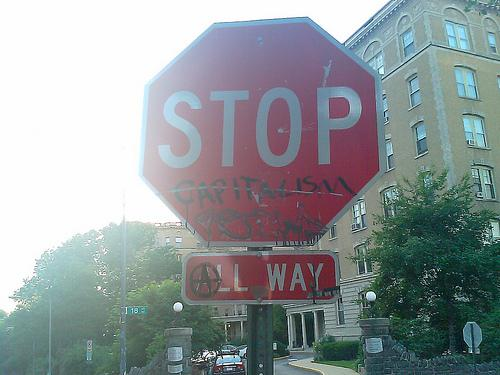Write a headline for a news article about the scene in the image. "Capitalism" Defaces Iconic Stop Sign in Bold Graffiti Statement. Pretend you are describing the image to someone who is blind. What details would you mention? In this image, there is a big red stop sign marked with black graffiti spelling out "capitalism". The sign stands near a big beige building and other urban elements. Pretend you are a tour guide. Briefly describe the scene in the image. On our left, we see a red stop sign with black graffiti, depicting the word "capitalism", near a large beige building. Describe the image as if it were a setting for a movie. In a bustling cityscape, the camera focuses on an unassuming stop sign, provocatively graffitied with the word "capitalism", heralding a tale of rebellion against the status quo. Narrate the scene in the image like a storyteller. Once upon a time, in a bustling city, there stood a stop sign, rebelliously adorned with a single word, "capitalism", written in black graffiti. Provide a poetic description of the image. Amidst the concrete jungle, a defiant statement sprawls upon a stop sign, where passing eyes must heed its command. Suppose you are an artist. Describe the image's main focal point and colors. A vibrant red stop sign, courageously marred by the strikingly contrasting black graffiti, captures the essence of modern urban life. In a few words, describe the primary focus of the image. Graffitied stop sign in urban setting. Mention the most noticeable element in the image and its characteristics. A large red stop sign with black graffiti, specifically the word "capitalism", stands out in the image. Imagine you are describing the image to a friend over the phone. Summarize the scene. There's this red stop sign with the word "capitalism" spray-painted in black right across it, in front of a large building. 